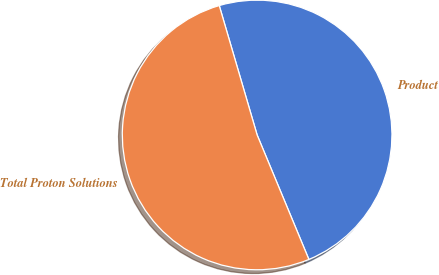Convert chart. <chart><loc_0><loc_0><loc_500><loc_500><pie_chart><fcel>Product<fcel>Total Proton Solutions<nl><fcel>48.26%<fcel>51.74%<nl></chart> 